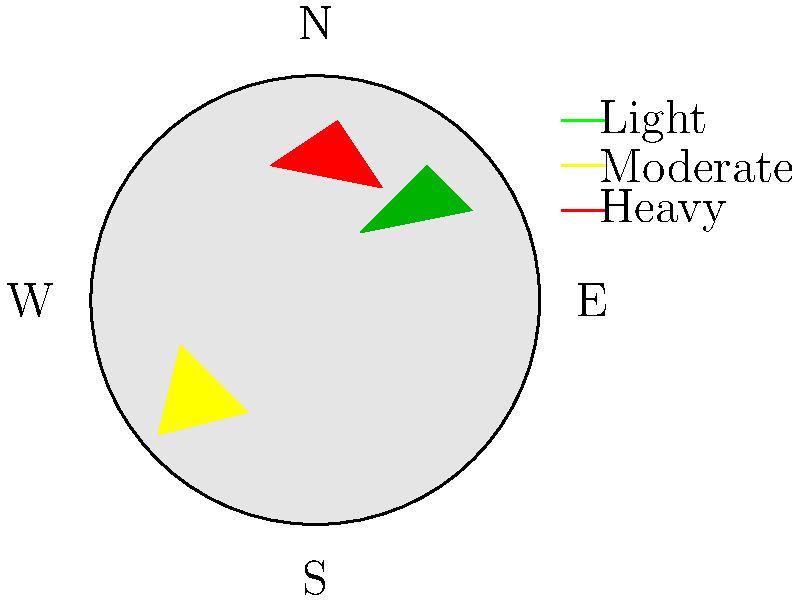Based on the weather radar image above, which direction is the precipitation most likely to move in the next few hours, and what type of precipitation intensity can be expected in the eastern part of the region? To answer this question, we need to analyze the radar image and apply our knowledge of weather patterns:

1. Orientation: The radar image shows a circular area with directional labels (N, S, E, W).

2. Precipitation areas:
   - Green area (light precipitation) in the upper right quadrant
   - Yellow area (moderate precipitation) in the lower left quadrant
   - Red area (heavy precipitation) in the upper left quadrant

3. Movement prediction:
   - In the Northern Hemisphere, weather systems typically move from west to east.
   - The arrangement of precipitation areas suggests a west-to-east movement.
   - The heaviest precipitation (red) is in the northwest, followed by moderate (yellow) in the southwest, and light (green) in the northeast.

4. Intensity prediction for the eastern region:
   - Currently, there is light precipitation (green) in the northeast.
   - Given the west-to-east movement, the moderate to heavy precipitation will likely move into the eastern region.

5. Conclusion:
   - The precipitation will most likely move eastward.
   - The eastern part of the region can expect increasing intensity, from light to moderate or heavy precipitation.
Answer: Eastward movement; increasing intensity (moderate to heavy precipitation) expected in the east. 